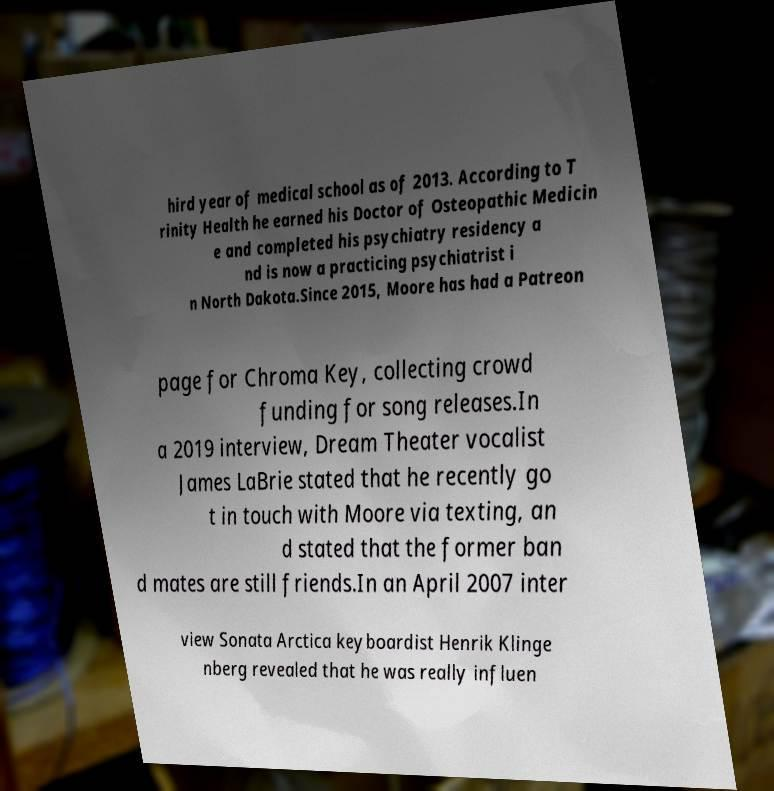There's text embedded in this image that I need extracted. Can you transcribe it verbatim? hird year of medical school as of 2013. According to T rinity Health he earned his Doctor of Osteopathic Medicin e and completed his psychiatry residency a nd is now a practicing psychiatrist i n North Dakota.Since 2015, Moore has had a Patreon page for Chroma Key, collecting crowd funding for song releases.In a 2019 interview, Dream Theater vocalist James LaBrie stated that he recently go t in touch with Moore via texting, an d stated that the former ban d mates are still friends.In an April 2007 inter view Sonata Arctica keyboardist Henrik Klinge nberg revealed that he was really influen 